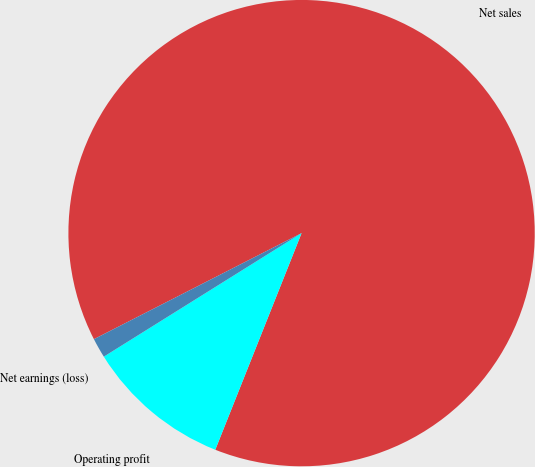Convert chart. <chart><loc_0><loc_0><loc_500><loc_500><pie_chart><fcel>Net sales<fcel>Operating profit<fcel>Net earnings (loss)<nl><fcel>88.55%<fcel>10.08%<fcel>1.37%<nl></chart> 